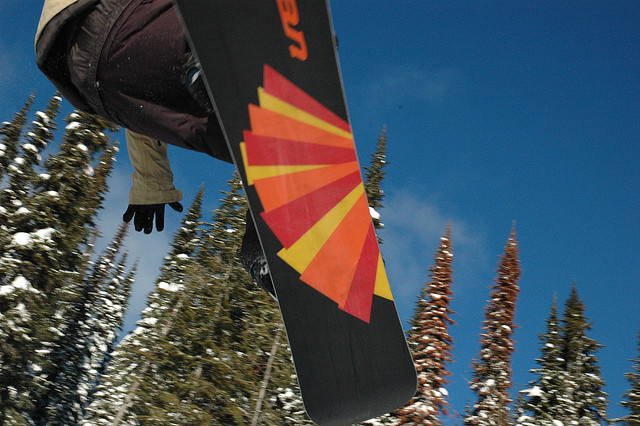<image>What letter is on the red flag? I don't know what letter is on the red flag, it can be 'n', 'f' or none. What letter is on the red flag? It is ambiguous what letter is on the red flag. It can be seen 'n', 'none', 'f' or unknown. 